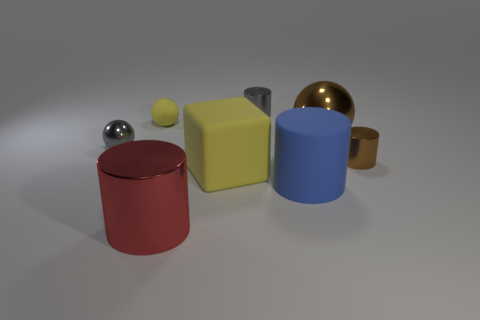Do the matte cylinder and the rubber thing that is left of the big yellow object have the same color?
Your response must be concise. No. What number of tiny red metallic things are there?
Offer a very short reply. 0. What number of objects are cyan shiny cylinders or brown spheres?
Offer a very short reply. 1. What size is the metallic cylinder that is the same color as the large sphere?
Provide a short and direct response. Small. There is a tiny gray cylinder; are there any blocks behind it?
Your answer should be very brief. No. Are there more small shiny cylinders that are on the left side of the small brown metal cylinder than gray things behind the big brown metal object?
Your response must be concise. No. What is the size of the gray shiny thing that is the same shape as the red metal thing?
Provide a succinct answer. Small. How many cylinders are big objects or brown metallic objects?
Give a very brief answer. 3. What material is the small thing that is the same color as the cube?
Make the answer very short. Rubber. Are there fewer brown balls in front of the large yellow object than tiny yellow rubber objects that are on the right side of the large brown metallic object?
Provide a succinct answer. No. 